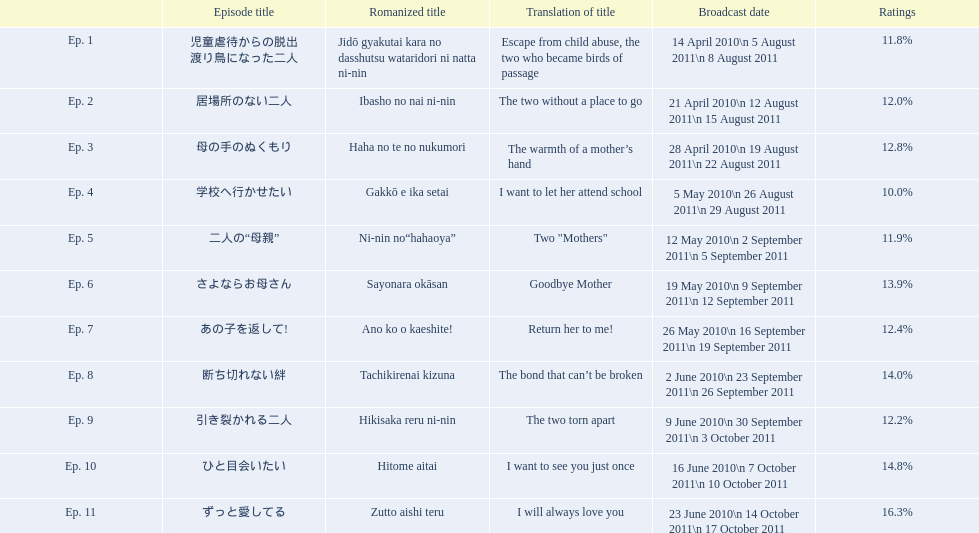What were the episode titles of mother? 児童虐待からの脱出 渡り鳥になった二人, 居場所のない二人, 母の手のぬくもり, 学校へ行かせたい, 二人の“母親”, さよならお母さん, あの子を返して!, 断ち切れない絆, 引き裂かれる二人, ひと目会いたい, ずっと愛してる. Which of these episodes had the highest ratings? ずっと愛してる. 